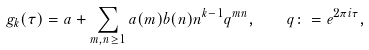Convert formula to latex. <formula><loc_0><loc_0><loc_500><loc_500>g _ { k } ( \tau ) = a + \sum _ { m , n \geq 1 } a ( m ) b ( n ) n ^ { k - 1 } q ^ { m n } , \quad q \colon = e ^ { 2 \pi i \tau } ,</formula> 